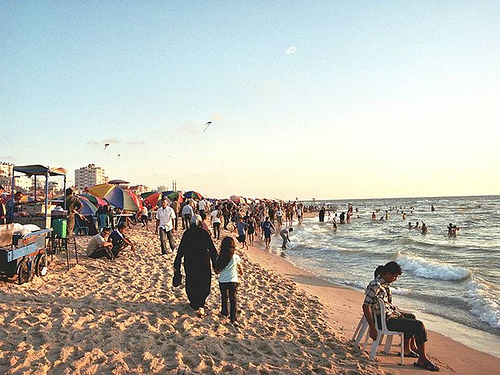Is the woman to the right of a person? No, the woman is walking alone with no one directly to her right at the moment the picture was taken. 